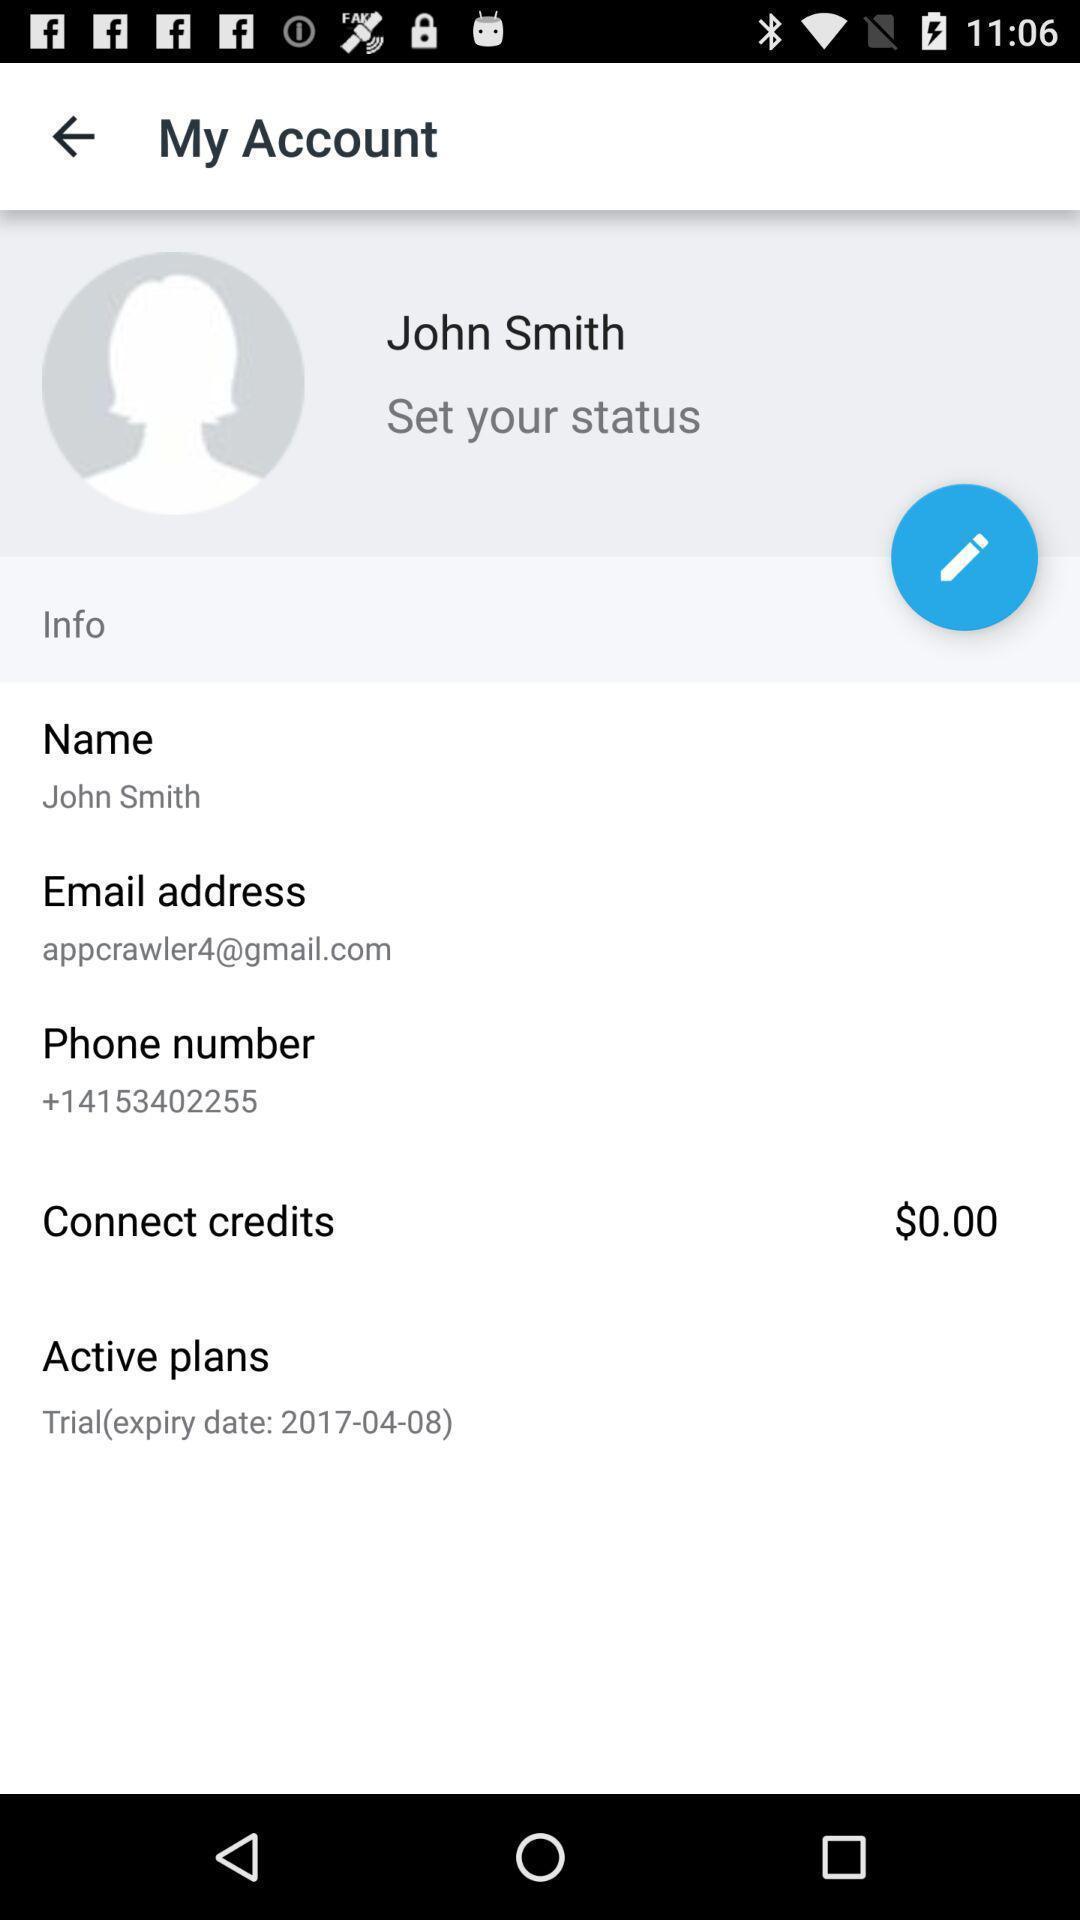Describe the visual elements of this screenshot. Page shows the user account information on social app. 